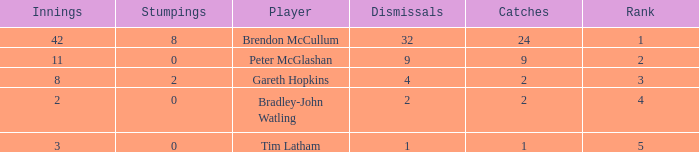List the ranks of all dismissals with a value of 4 3.0. 